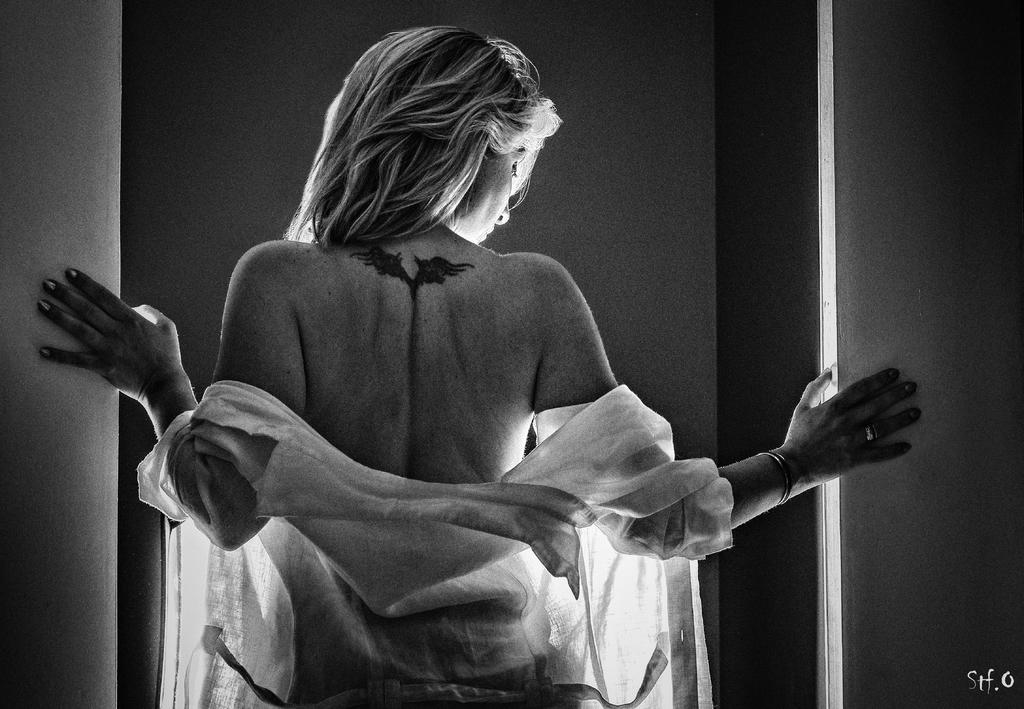Who is the main subject in the image? There is a woman in the image. Where is the woman positioned in the image? The woman is standing in the middle of the image. What is the woman wearing in the image? The woman is wearing a white dress. What type of camera is the woman using in the image? There is no camera present in the image, and the woman is not using one. 